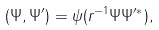<formula> <loc_0><loc_0><loc_500><loc_500>( \Psi , \Psi ^ { \prime } ) = \psi ( { r } ^ { - 1 } \Psi \Psi ^ { \prime * } ) ,</formula> 